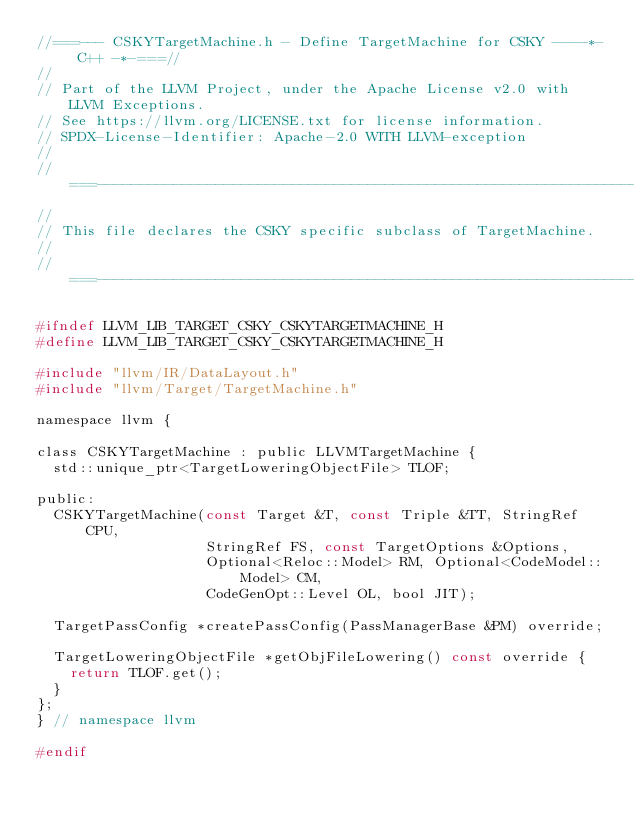<code> <loc_0><loc_0><loc_500><loc_500><_C_>//===--- CSKYTargetMachine.h - Define TargetMachine for CSKY ----*- C++ -*-===//
//
// Part of the LLVM Project, under the Apache License v2.0 with LLVM Exceptions.
// See https://llvm.org/LICENSE.txt for license information.
// SPDX-License-Identifier: Apache-2.0 WITH LLVM-exception
//
//===----------------------------------------------------------------------===//
//
// This file declares the CSKY specific subclass of TargetMachine.
//
//===----------------------------------------------------------------------===//

#ifndef LLVM_LIB_TARGET_CSKY_CSKYTARGETMACHINE_H
#define LLVM_LIB_TARGET_CSKY_CSKYTARGETMACHINE_H

#include "llvm/IR/DataLayout.h"
#include "llvm/Target/TargetMachine.h"

namespace llvm {

class CSKYTargetMachine : public LLVMTargetMachine {
  std::unique_ptr<TargetLoweringObjectFile> TLOF;

public:
  CSKYTargetMachine(const Target &T, const Triple &TT, StringRef CPU,
                    StringRef FS, const TargetOptions &Options,
                    Optional<Reloc::Model> RM, Optional<CodeModel::Model> CM,
                    CodeGenOpt::Level OL, bool JIT);

  TargetPassConfig *createPassConfig(PassManagerBase &PM) override;

  TargetLoweringObjectFile *getObjFileLowering() const override {
    return TLOF.get();
  }
};
} // namespace llvm

#endif
</code> 